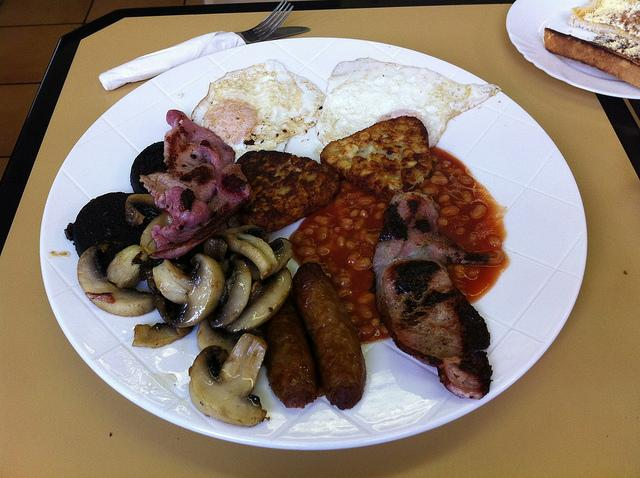How many eggs are served beside the hash browns in this breakfast plate? Please explain your reasoning. two. There are two eggs on the top of the plate. 